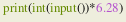<code> <loc_0><loc_0><loc_500><loc_500><_Python_>print(int(input())*6.28)</code> 